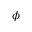Convert formula to latex. <formula><loc_0><loc_0><loc_500><loc_500>\phi</formula> 